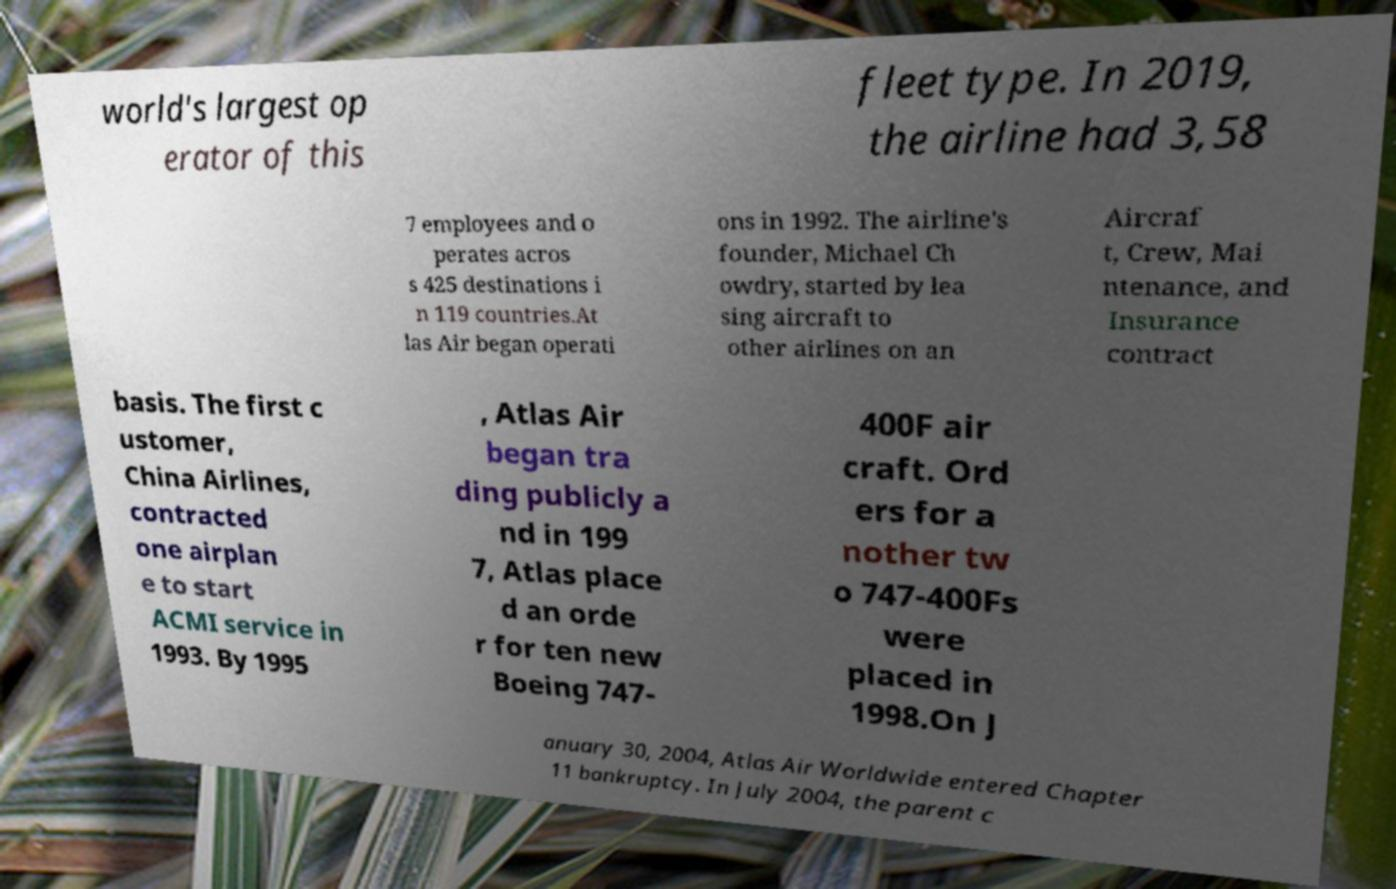What messages or text are displayed in this image? I need them in a readable, typed format. world's largest op erator of this fleet type. In 2019, the airline had 3,58 7 employees and o perates acros s 425 destinations i n 119 countries.At las Air began operati ons in 1992. The airline's founder, Michael Ch owdry, started by lea sing aircraft to other airlines on an Aircraf t, Crew, Mai ntenance, and Insurance contract basis. The first c ustomer, China Airlines, contracted one airplan e to start ACMI service in 1993. By 1995 , Atlas Air began tra ding publicly a nd in 199 7, Atlas place d an orde r for ten new Boeing 747- 400F air craft. Ord ers for a nother tw o 747-400Fs were placed in 1998.On J anuary 30, 2004, Atlas Air Worldwide entered Chapter 11 bankruptcy. In July 2004, the parent c 